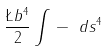Convert formula to latex. <formula><loc_0><loc_0><loc_500><loc_500>\frac { \L b ^ { 4 } } { 2 } \int \, - \ d s ^ { 4 }</formula> 